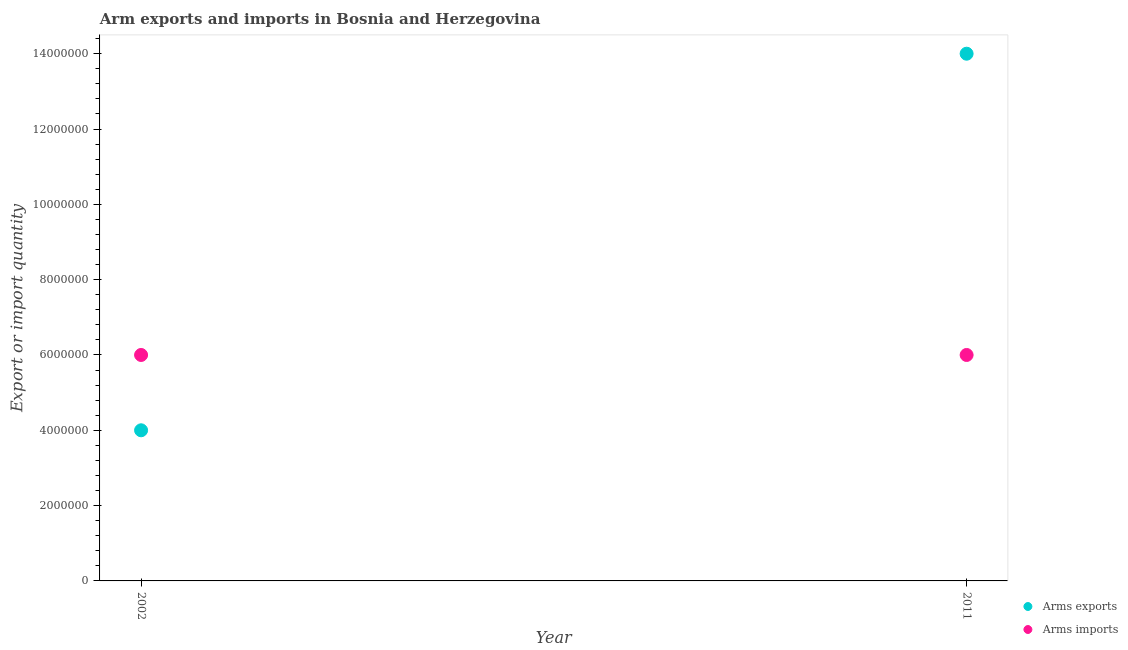How many different coloured dotlines are there?
Provide a succinct answer. 2. What is the arms imports in 2011?
Your response must be concise. 6.00e+06. Across all years, what is the maximum arms imports?
Keep it short and to the point. 6.00e+06. Across all years, what is the minimum arms exports?
Offer a terse response. 4.00e+06. In which year was the arms imports maximum?
Provide a short and direct response. 2002. In which year was the arms exports minimum?
Make the answer very short. 2002. What is the total arms exports in the graph?
Your response must be concise. 1.80e+07. What is the difference between the arms exports in 2002 and that in 2011?
Keep it short and to the point. -1.00e+07. What is the difference between the arms exports in 2011 and the arms imports in 2002?
Your answer should be very brief. 8.00e+06. What is the average arms exports per year?
Provide a succinct answer. 9.00e+06. In the year 2002, what is the difference between the arms exports and arms imports?
Keep it short and to the point. -2.00e+06. In how many years, is the arms imports greater than the average arms imports taken over all years?
Give a very brief answer. 0. Is the arms imports strictly greater than the arms exports over the years?
Your answer should be very brief. No. Is the arms exports strictly less than the arms imports over the years?
Make the answer very short. No. How many dotlines are there?
Your answer should be very brief. 2. What is the difference between two consecutive major ticks on the Y-axis?
Offer a very short reply. 2.00e+06. Where does the legend appear in the graph?
Ensure brevity in your answer.  Bottom right. How many legend labels are there?
Provide a short and direct response. 2. What is the title of the graph?
Your response must be concise. Arm exports and imports in Bosnia and Herzegovina. Does "Tetanus" appear as one of the legend labels in the graph?
Offer a very short reply. No. What is the label or title of the X-axis?
Provide a short and direct response. Year. What is the label or title of the Y-axis?
Provide a succinct answer. Export or import quantity. What is the Export or import quantity of Arms exports in 2002?
Offer a terse response. 4.00e+06. What is the Export or import quantity in Arms imports in 2002?
Your answer should be very brief. 6.00e+06. What is the Export or import quantity of Arms exports in 2011?
Offer a very short reply. 1.40e+07. What is the Export or import quantity of Arms imports in 2011?
Your answer should be very brief. 6.00e+06. Across all years, what is the maximum Export or import quantity of Arms exports?
Your response must be concise. 1.40e+07. What is the total Export or import quantity in Arms exports in the graph?
Offer a very short reply. 1.80e+07. What is the total Export or import quantity of Arms imports in the graph?
Provide a short and direct response. 1.20e+07. What is the difference between the Export or import quantity of Arms exports in 2002 and that in 2011?
Ensure brevity in your answer.  -1.00e+07. What is the difference between the Export or import quantity of Arms imports in 2002 and that in 2011?
Give a very brief answer. 0. What is the average Export or import quantity of Arms exports per year?
Your answer should be compact. 9.00e+06. What is the average Export or import quantity in Arms imports per year?
Your answer should be compact. 6.00e+06. In the year 2002, what is the difference between the Export or import quantity of Arms exports and Export or import quantity of Arms imports?
Provide a succinct answer. -2.00e+06. In the year 2011, what is the difference between the Export or import quantity of Arms exports and Export or import quantity of Arms imports?
Keep it short and to the point. 8.00e+06. What is the ratio of the Export or import quantity in Arms exports in 2002 to that in 2011?
Offer a very short reply. 0.29. What is the ratio of the Export or import quantity in Arms imports in 2002 to that in 2011?
Provide a succinct answer. 1. What is the difference between the highest and the lowest Export or import quantity of Arms exports?
Offer a terse response. 1.00e+07. What is the difference between the highest and the lowest Export or import quantity in Arms imports?
Provide a short and direct response. 0. 